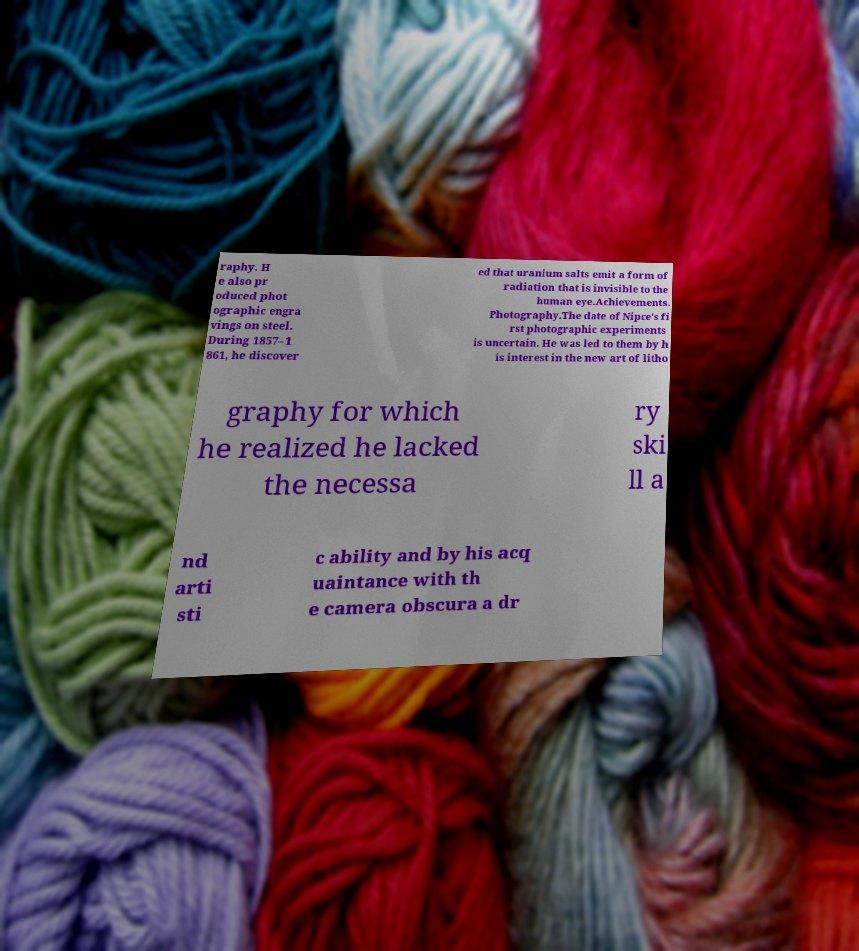Could you extract and type out the text from this image? raphy. H e also pr oduced phot ographic engra vings on steel. During 1857–1 861, he discover ed that uranium salts emit a form of radiation that is invisible to the human eye.Achievements. Photography.The date of Nipce's fi rst photographic experiments is uncertain. He was led to them by h is interest in the new art of litho graphy for which he realized he lacked the necessa ry ski ll a nd arti sti c ability and by his acq uaintance with th e camera obscura a dr 